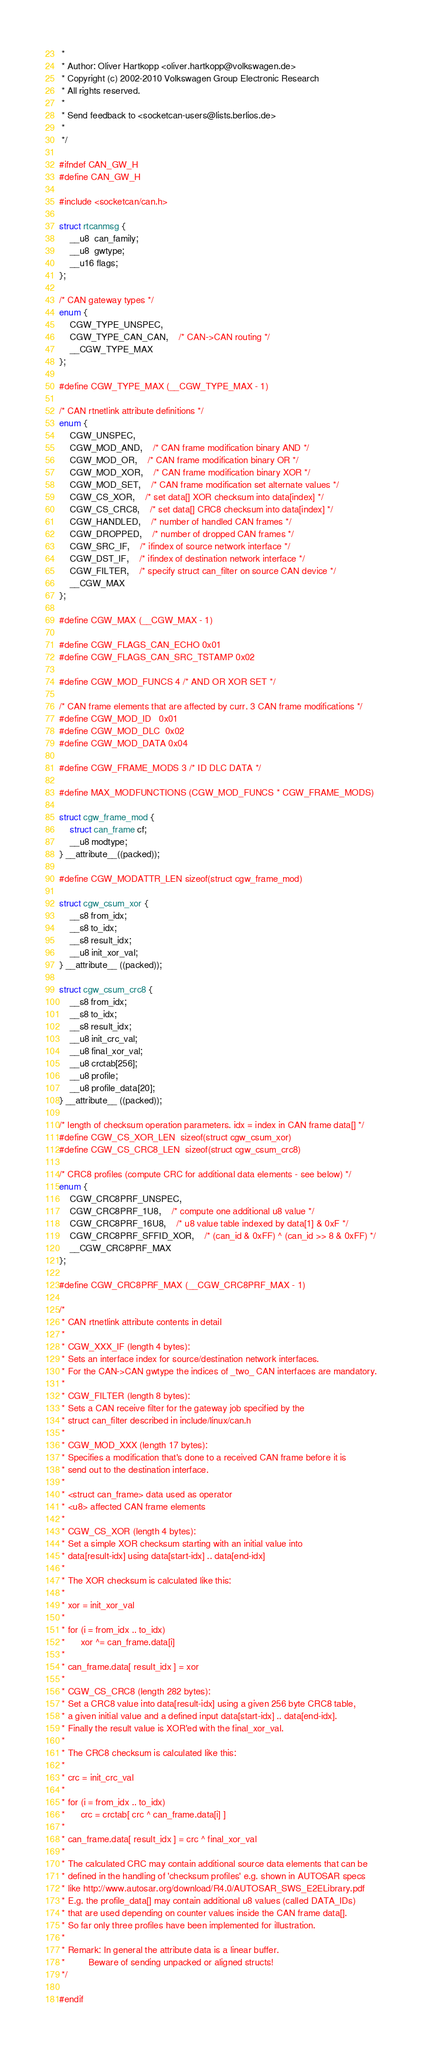Convert code to text. <code><loc_0><loc_0><loc_500><loc_500><_C_> *
 * Author: Oliver Hartkopp <oliver.hartkopp@volkswagen.de>
 * Copyright (c) 2002-2010 Volkswagen Group Electronic Research
 * All rights reserved.
 *
 * Send feedback to <socketcan-users@lists.berlios.de>
 *
 */

#ifndef CAN_GW_H
#define CAN_GW_H

#include <socketcan/can.h>

struct rtcanmsg {
	__u8  can_family;
	__u8  gwtype;
	__u16 flags;
};

/* CAN gateway types */
enum {
	CGW_TYPE_UNSPEC,
	CGW_TYPE_CAN_CAN,	/* CAN->CAN routing */
	__CGW_TYPE_MAX
};

#define CGW_TYPE_MAX (__CGW_TYPE_MAX - 1)

/* CAN rtnetlink attribute definitions */
enum {
	CGW_UNSPEC,
	CGW_MOD_AND,	/* CAN frame modification binary AND */
	CGW_MOD_OR,	/* CAN frame modification binary OR */
	CGW_MOD_XOR,	/* CAN frame modification binary XOR */
	CGW_MOD_SET,	/* CAN frame modification set alternate values */
	CGW_CS_XOR,	/* set data[] XOR checksum into data[index] */
	CGW_CS_CRC8,	/* set data[] CRC8 checksum into data[index] */
	CGW_HANDLED,	/* number of handled CAN frames */
	CGW_DROPPED,	/* number of dropped CAN frames */
	CGW_SRC_IF,	/* ifindex of source network interface */
	CGW_DST_IF,	/* ifindex of destination network interface */
	CGW_FILTER,	/* specify struct can_filter on source CAN device */
	__CGW_MAX
};

#define CGW_MAX (__CGW_MAX - 1)

#define CGW_FLAGS_CAN_ECHO 0x01
#define CGW_FLAGS_CAN_SRC_TSTAMP 0x02

#define CGW_MOD_FUNCS 4 /* AND OR XOR SET */

/* CAN frame elements that are affected by curr. 3 CAN frame modifications */
#define CGW_MOD_ID	0x01
#define CGW_MOD_DLC	0x02
#define CGW_MOD_DATA	0x04

#define CGW_FRAME_MODS 3 /* ID DLC DATA */

#define MAX_MODFUNCTIONS (CGW_MOD_FUNCS * CGW_FRAME_MODS)

struct cgw_frame_mod {
	struct can_frame cf;
	__u8 modtype;
} __attribute__((packed));

#define CGW_MODATTR_LEN sizeof(struct cgw_frame_mod)

struct cgw_csum_xor {
	__s8 from_idx;
	__s8 to_idx;
	__s8 result_idx;
	__u8 init_xor_val;
} __attribute__ ((packed));

struct cgw_csum_crc8 {
	__s8 from_idx;
	__s8 to_idx;
	__s8 result_idx;
	__u8 init_crc_val;
	__u8 final_xor_val;
	__u8 crctab[256];
	__u8 profile;
	__u8 profile_data[20];
} __attribute__ ((packed));

/* length of checksum operation parameters. idx = index in CAN frame data[] */
#define CGW_CS_XOR_LEN  sizeof(struct cgw_csum_xor)
#define CGW_CS_CRC8_LEN  sizeof(struct cgw_csum_crc8)

/* CRC8 profiles (compute CRC for additional data elements - see below) */
enum {
	CGW_CRC8PRF_UNSPEC,
	CGW_CRC8PRF_1U8,	/* compute one additional u8 value */
	CGW_CRC8PRF_16U8,	/* u8 value table indexed by data[1] & 0xF */
	CGW_CRC8PRF_SFFID_XOR,	/* (can_id & 0xFF) ^ (can_id >> 8 & 0xFF) */
	__CGW_CRC8PRF_MAX
};

#define CGW_CRC8PRF_MAX (__CGW_CRC8PRF_MAX - 1)

/*
 * CAN rtnetlink attribute contents in detail
 *
 * CGW_XXX_IF (length 4 bytes):
 * Sets an interface index for source/destination network interfaces.
 * For the CAN->CAN gwtype the indices of _two_ CAN interfaces are mandatory.
 *
 * CGW_FILTER (length 8 bytes):
 * Sets a CAN receive filter for the gateway job specified by the
 * struct can_filter described in include/linux/can.h
 *
 * CGW_MOD_XXX (length 17 bytes):
 * Specifies a modification that's done to a received CAN frame before it is
 * send out to the destination interface.
 *
 * <struct can_frame> data used as operator
 * <u8> affected CAN frame elements
 *
 * CGW_CS_XOR (length 4 bytes):
 * Set a simple XOR checksum starting with an initial value into
 * data[result-idx] using data[start-idx] .. data[end-idx]
 *
 * The XOR checksum is calculated like this:
 *
 * xor = init_xor_val
 * 
 * for (i = from_idx .. to_idx)
 *      xor ^= can_frame.data[i]
 *
 * can_frame.data[ result_idx ] = xor
 *
 * CGW_CS_CRC8 (length 282 bytes):
 * Set a CRC8 value into data[result-idx] using a given 256 byte CRC8 table,
 * a given initial value and a defined input data[start-idx] .. data[end-idx].
 * Finally the result value is XOR'ed with the final_xor_val.
 *
 * The CRC8 checksum is calculated like this:
 *
 * crc = init_crc_val
 * 
 * for (i = from_idx .. to_idx)
 *      crc = crctab[ crc ^ can_frame.data[i] ]
 *
 * can_frame.data[ result_idx ] = crc ^ final_xor_val
 *
 * The calculated CRC may contain additional source data elements that can be
 * defined in the handling of 'checksum profiles' e.g. shown in AUTOSAR specs
 * like http://www.autosar.org/download/R4.0/AUTOSAR_SWS_E2ELibrary.pdf
 * E.g. the profile_data[] may contain additional u8 values (called DATA_IDs)
 * that are used depending on counter values inside the CAN frame data[].
 * So far only three profiles have been implemented for illustration.
 *
 * Remark: In general the attribute data is a linear buffer.
 *         Beware of sending unpacked or aligned structs!
 */

#endif
</code> 